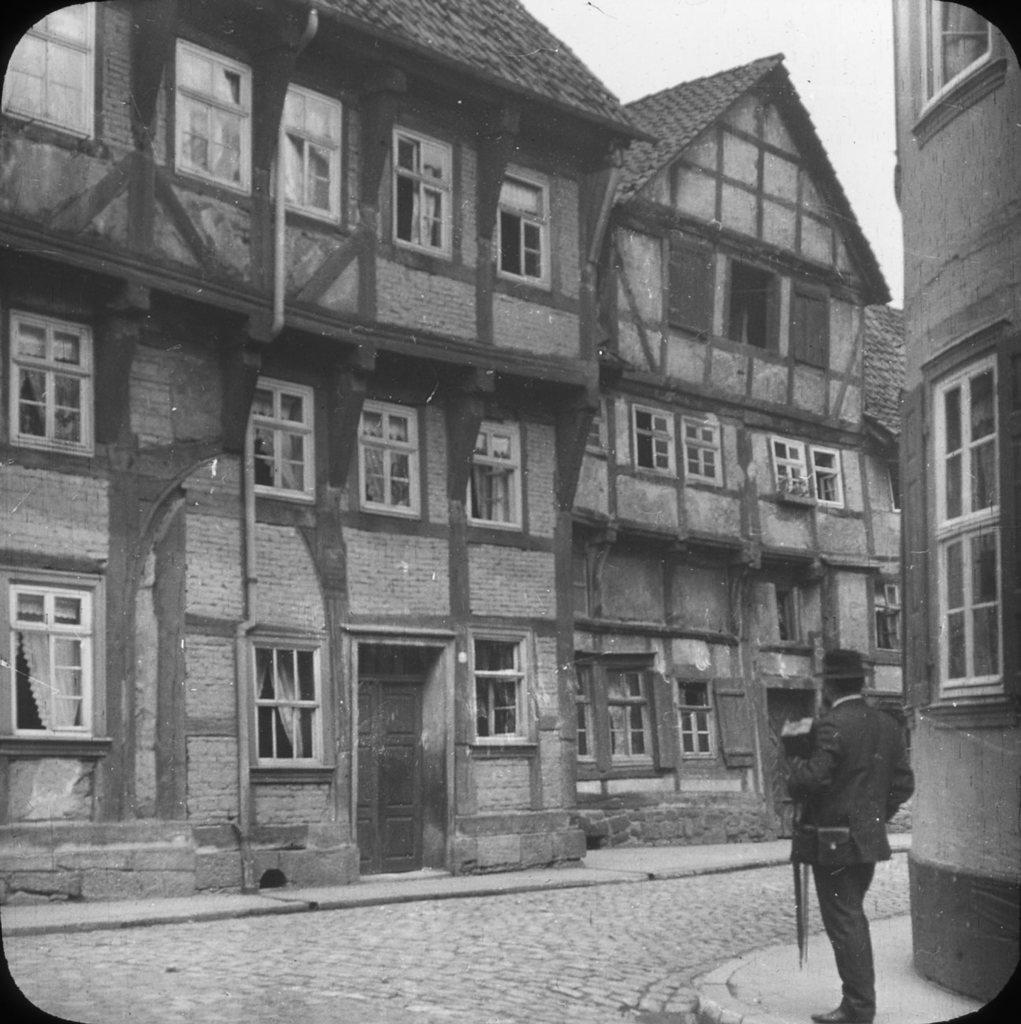What is the main subject of the image? There is a person standing in the image. What is located in front of the person? There is a building in front of the person. What can be seen in the background of the image? The sky is visible in the image. What is the color scheme of the image? The image is in black and white. What type of treatment is the person receiving in the image? There is no indication of any treatment being administered in the image; it simply shows a person standing in front of a building. Are the police present in the image? There is no mention of police or any law enforcement personnel in the image. 